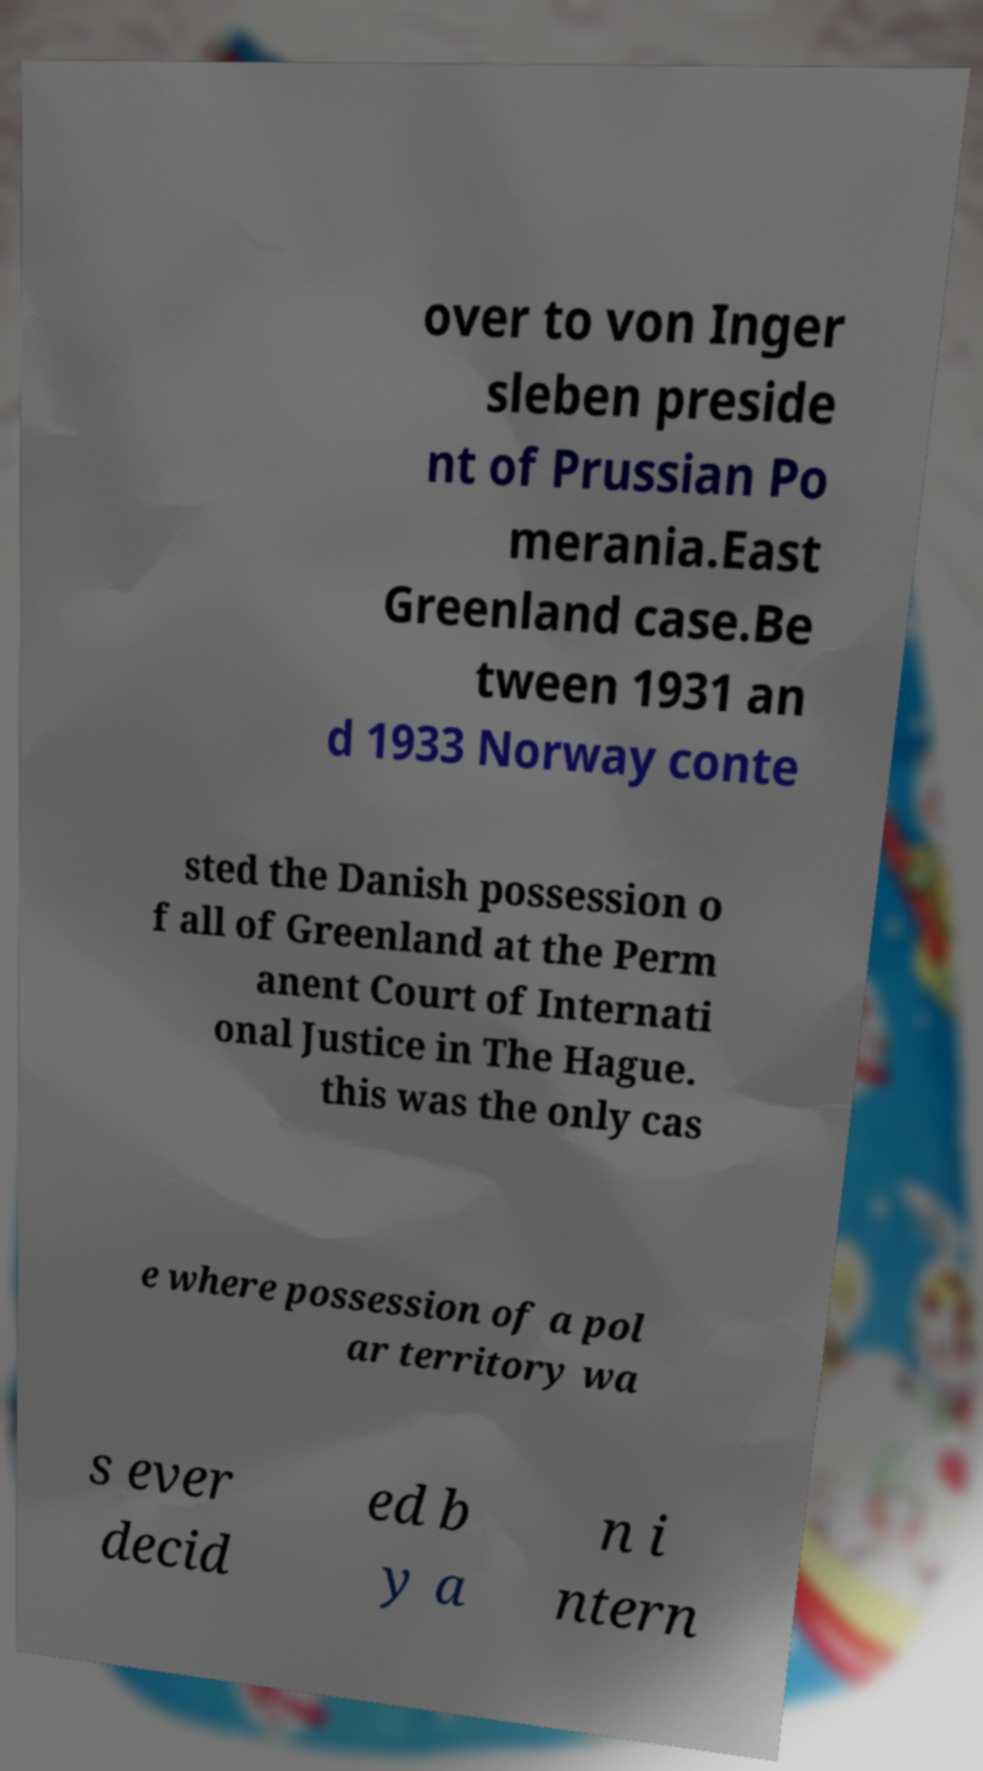Could you extract and type out the text from this image? over to von Inger sleben preside nt of Prussian Po merania.East Greenland case.Be tween 1931 an d 1933 Norway conte sted the Danish possession o f all of Greenland at the Perm anent Court of Internati onal Justice in The Hague. this was the only cas e where possession of a pol ar territory wa s ever decid ed b y a n i ntern 